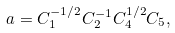<formula> <loc_0><loc_0><loc_500><loc_500>a = C _ { 1 } ^ { - 1 / 2 } C _ { 2 } ^ { - 1 } C _ { 4 } ^ { 1 / 2 } C _ { 5 } ,</formula> 